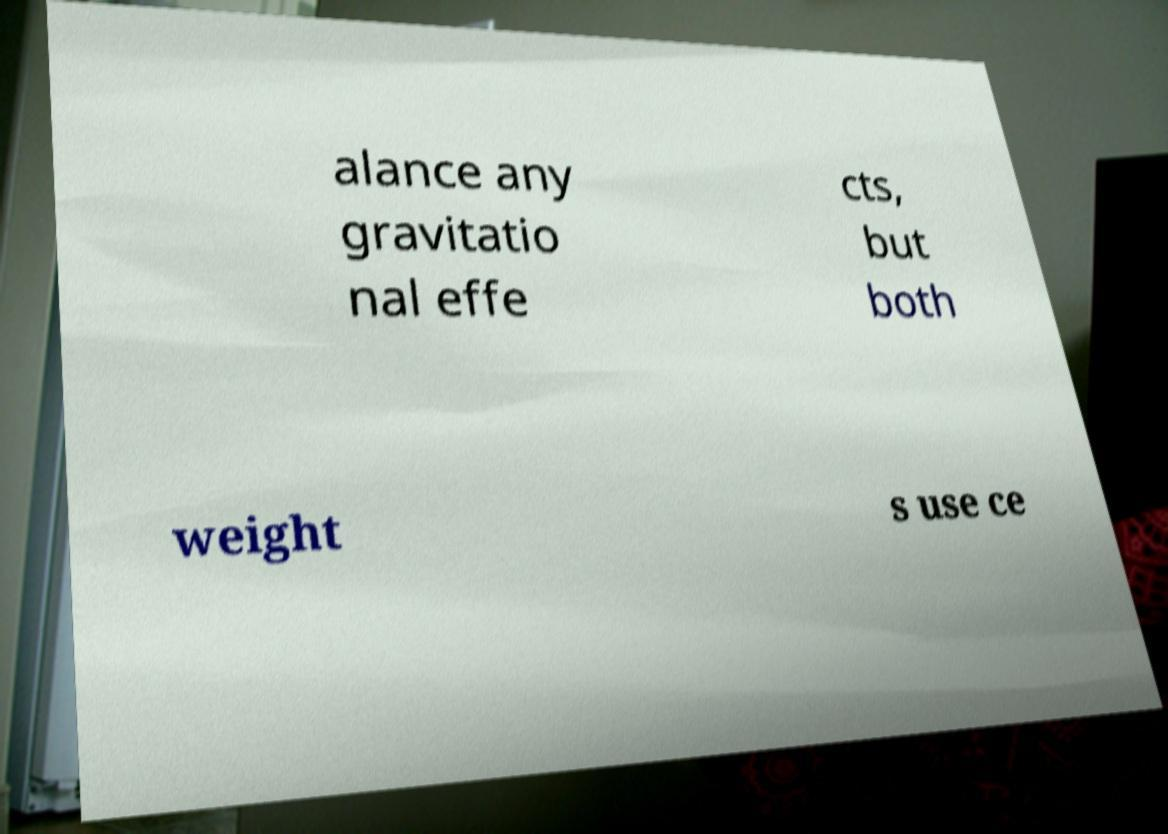Please identify and transcribe the text found in this image. alance any gravitatio nal effe cts, but both weight s use ce 